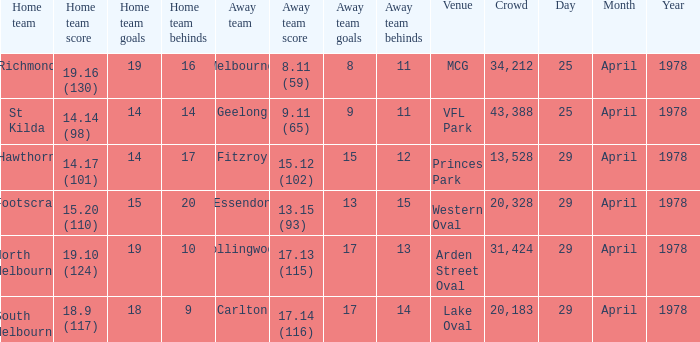Who was the home team at MCG? Richmond. 